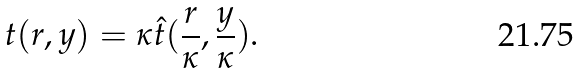<formula> <loc_0><loc_0><loc_500><loc_500>t ( r , y ) = \kappa \hat { t } ( \frac { r } { \kappa } , \frac { y } { \kappa } ) .</formula> 